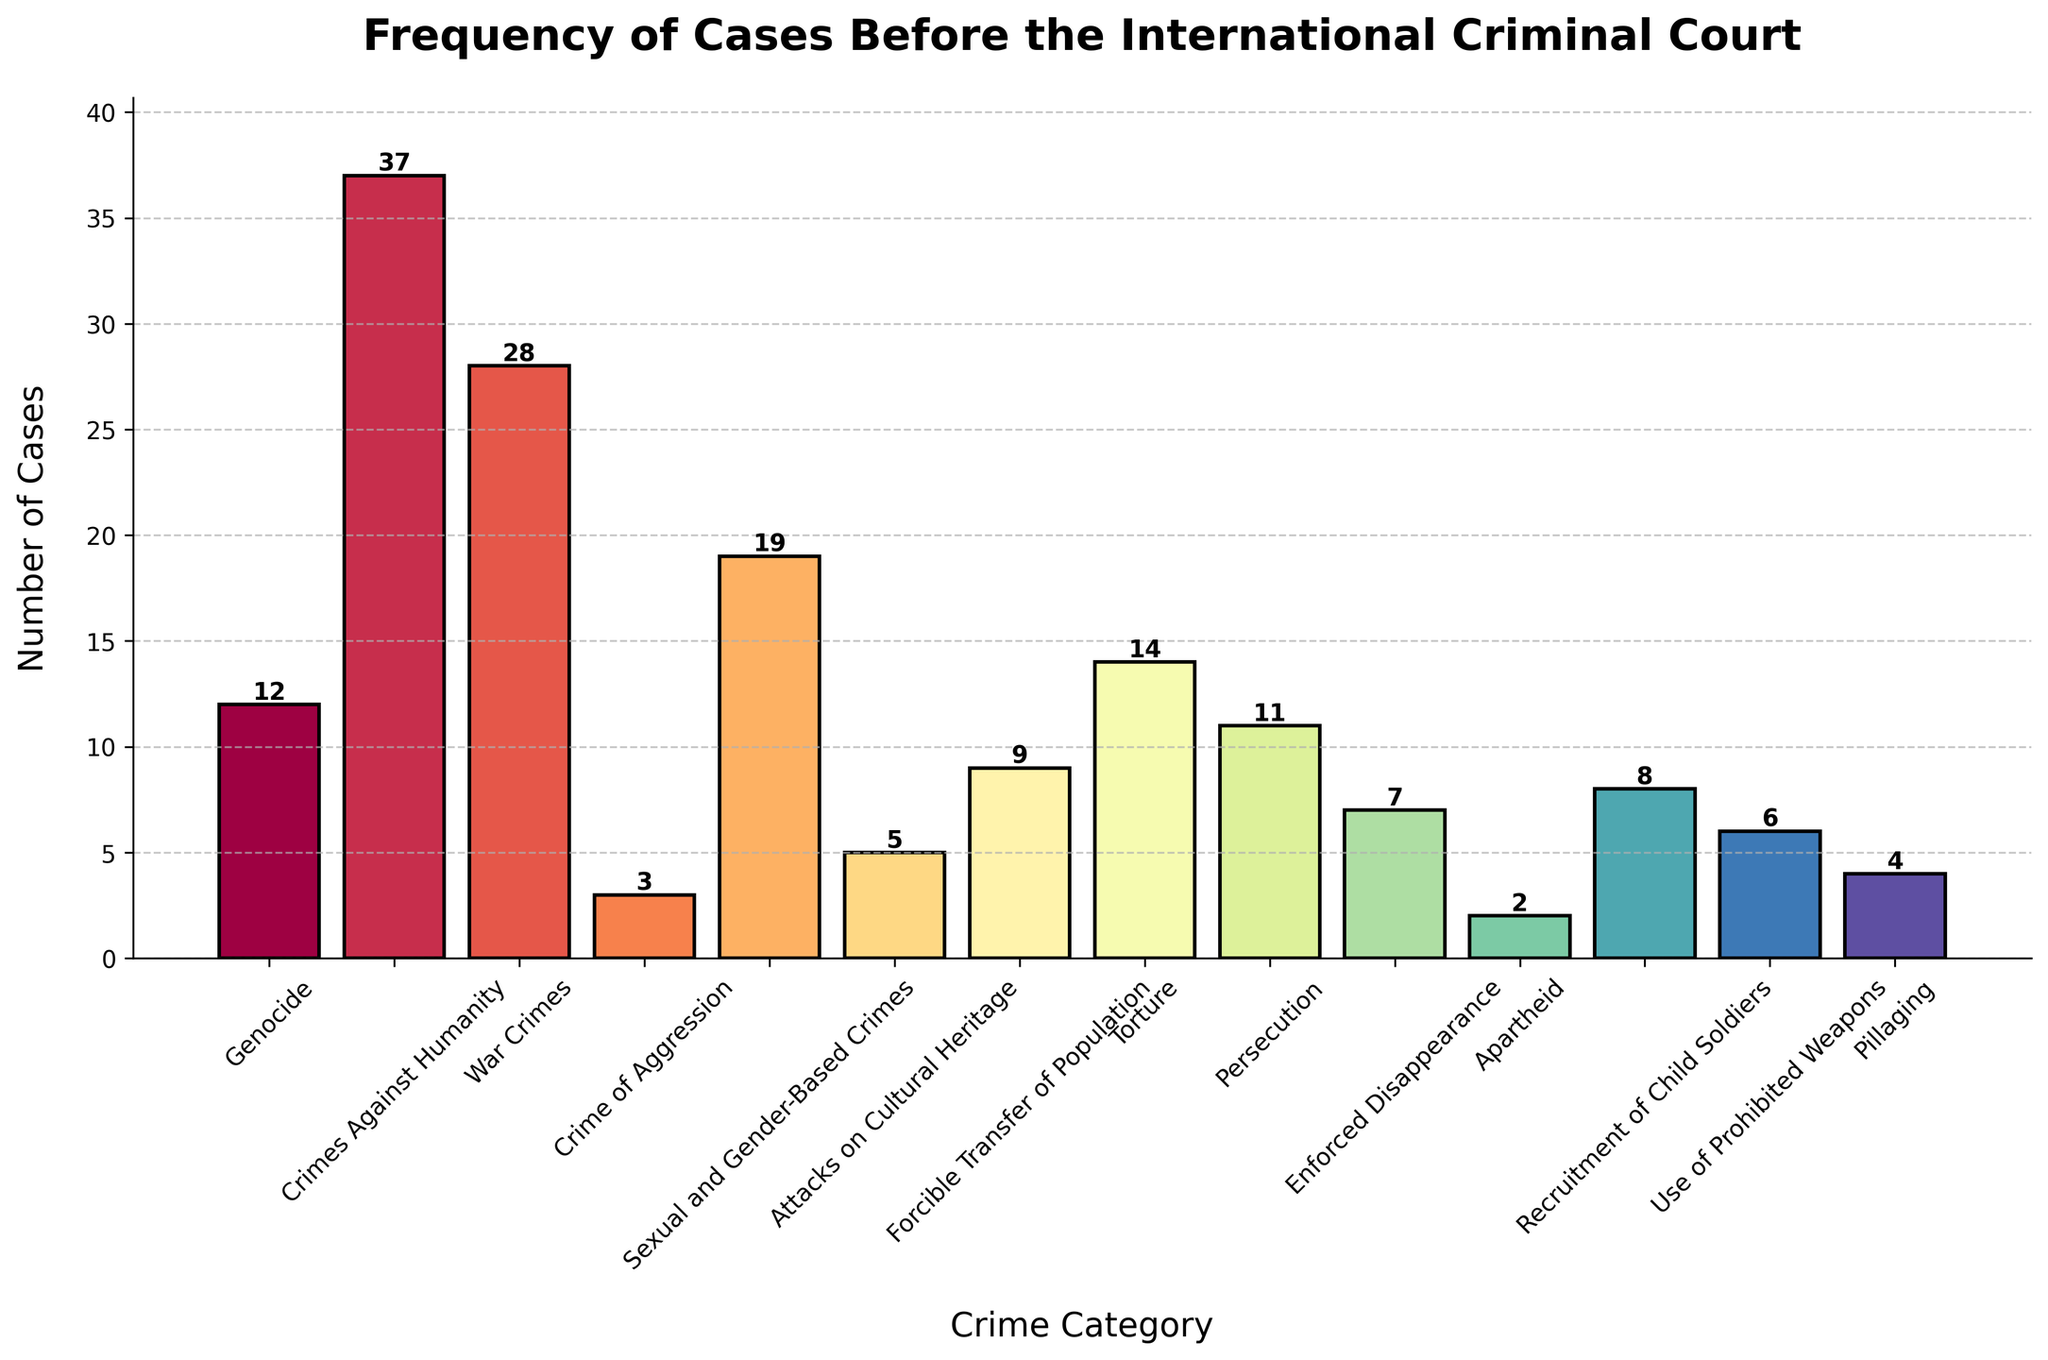Which crime category has the highest number of cases? To find the crime category with the highest number of cases, look for the tallest bar in the chart. The tallest bar represents 'Crimes Against Humanity' with 37 cases.
Answer: Crimes Against Humanity What is the total number of cases for Genocide and War Crimes combined? Add the number of cases for Genocide (12) and War Crimes (28) together: 12 + 28 = 40.
Answer: 40 How does the number of cases for Sexual and Gender-Based Crimes compare to Torture? Compare the height of the bars for Sexual and Gender-Based Crimes and Torture. Sexual and Gender-Based Crimes (19) has more cases than Torture (14).
Answer: Sexual and Gender-Based Crimes have more cases Which crime category has the fewest number of cases? Identify the shortest bar in the chart. The shortest bar represents 'Apartheid' with 2 cases.
Answer: Apartheid What is the total number of cases across all crime categories? Add up the values for all crime categories: 12 + 37 + 28 + 3 + 19 + 5 + 9 + 14 + 11 + 7 + 2 + 8 + 6 + 4 = 165.
Answer: 165 What is the difference in the number of cases between Persecution and Enforced Disappearance? Subtract the number of cases for Enforced Disappearance (7) from Persecution (11): 11 - 7 = 4.
Answer: 4 Which crime categories have more than 10 cases but fewer than 20 cases? Look for bars with heights between 10 and 20. The categories are Sexual and Gender-Based Crimes (19), Torture (14), and Genocide (12).
Answer: Sexual and Gender-Based Crimes, Torture, Genocide How many more cases are there for Crimes Against Humanity than for the Use of Prohibited Weapons? Subtract the number of cases for Use of Prohibited Weapons (6) from Crimes Against Humanity (37): 37 - 6 = 31.
Answer: 31 What is the average number of cases per crime category? Divide the total number of cases (165) by the number of crime categories (14): 165 / 14 ≈ 11.79.
Answer: ≈ 11.79 Are there more cases of Recruitment of Child Soldiers or Crimes Against Humanity? Compare the heights of the bars for Recruitment of Child Soldiers and Crimes Against Humanity. Crimes Against Humanity (37) has more cases than Recruitment of Child Soldiers (8).
Answer: Crimes Against Humanity 